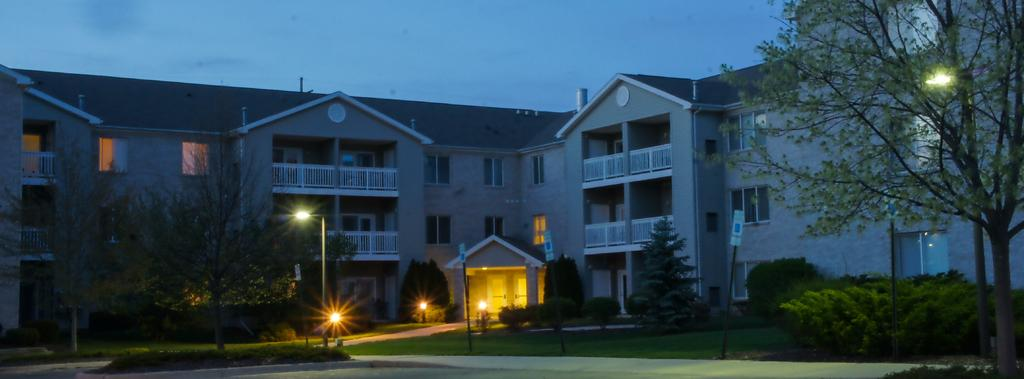What type of structures are visible in the image? There are buildings in the image. What can be seen on the buildings in the image? There are windows and lights visible on the buildings in the image. What type of vegetation is present in the image? There are plants, trees, and grass visible in the image. What is visible at the top of the image? The sky is visible at the top of the image. How would you describe the lighting in the image? The image appears to be slightly dark. What type of wool is being carried in the pocket of the person in the image? There is no person or wool present in the image. What knowledge can be gained from the image? The image does not convey any specific knowledge or information beyond the visible subjects and objects. 